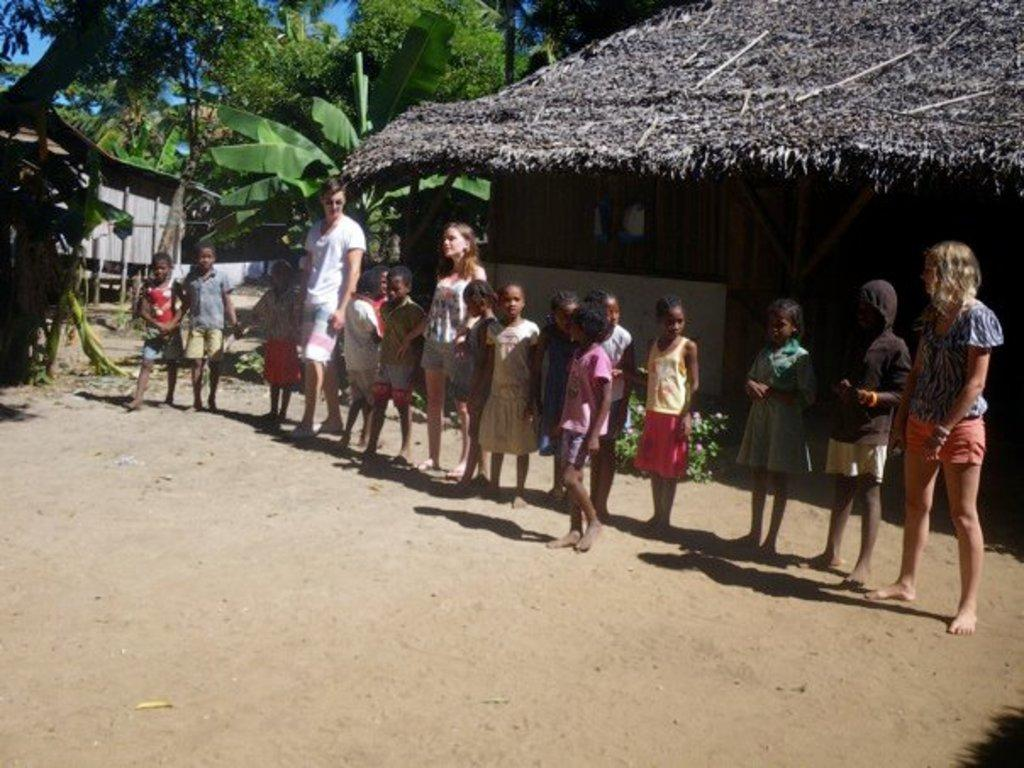What can be seen in the foreground of the image? There are people standing in front of a hut. What is visible in the background of the image? There are trees and plants beside the hut. Are there any other structures visible in the image? Yes, there is another hut on the left side of the image. What type of drug can be seen in the image? There is no drug present in the image. How many ducks are visible in the image? There are no ducks present in the image. 